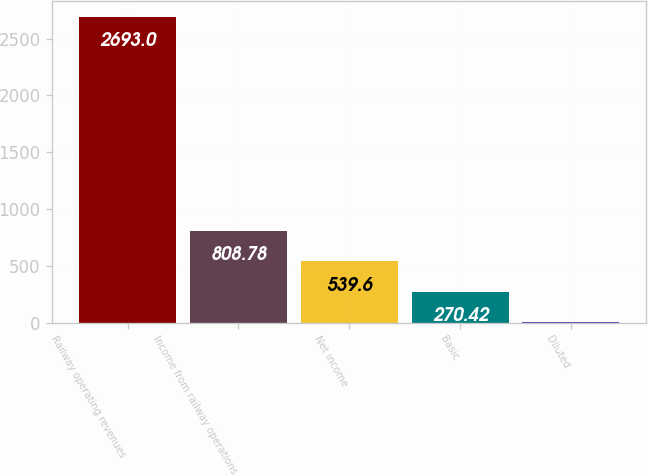Convert chart to OTSL. <chart><loc_0><loc_0><loc_500><loc_500><bar_chart><fcel>Railway operating revenues<fcel>Income from railway operations<fcel>Net income<fcel>Basic<fcel>Diluted<nl><fcel>2693<fcel>808.78<fcel>539.6<fcel>270.42<fcel>1.24<nl></chart> 